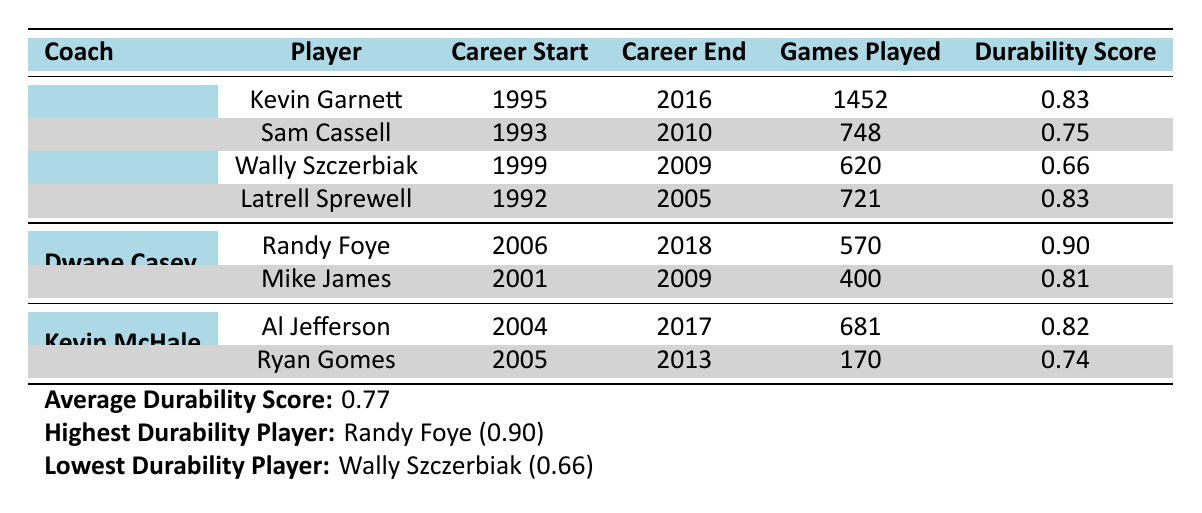What is the durability score of Kevin Garnett? The table indicates that Kevin Garnett has a durability score of 0.83, which can be found in the row corresponding to him under Flip Saunders' coaching.
Answer: 0.83 Which player has the highest durability score? The derived metrics section shows that Randy Foye has the highest durability score of 0.90, which can be verified in the table under Dwane Casey's coaching.
Answer: Randy Foye (0.90) How many games did Sam Cassell play during his career? According to the table, Sam Cassell played a total of 748 games, as stated in the row corresponding to him under Flip Saunders’ coaching.
Answer: 748 What is the average durability score of all players listed? The derived metrics section provides the average durability score of all players, which is calculated as 0.77. This value is stated at the bottom of the table.
Answer: 0.77 Did Latrell Sprewell play more games than Wally Szczerbiak? The table indicates that Latrell Sprewell played 721 games while Wally Szczerbiak played 620 games. Therefore, Latrell Sprewell played more games than Wally Szczerbiak.
Answer: Yes Which coach had players with the lowest durability score? The table reveals that under Flip Saunders' coaching, Wally Szczerbiak had the lowest durability score of 0.66 compared to all players in the table.
Answer: Flip Saunders How many injury days did Al Jefferson have during his career? By checking the table, Al Jefferson has 125 injury days listed in the row corresponding to him under Kevin McHale's coaching.
Answer: 125 What is the difference in games played between Kevin Garnett and Al Jefferson? Kevin Garnett played 1452 games, and Al Jefferson played 681 games. To find the difference: 1452 - 681 = 771. Therefore, the difference in games played is 771.
Answer: 771 Did any player under Dwane Casey have a durability score below 0.80? The table indicates that Mike James has a durability score of 0.81, which is above 0.80, and Randy Foye has a score of 0.90, which is also above. Therefore, no players under Dwane Casey had a score below 0.80.
Answer: No 